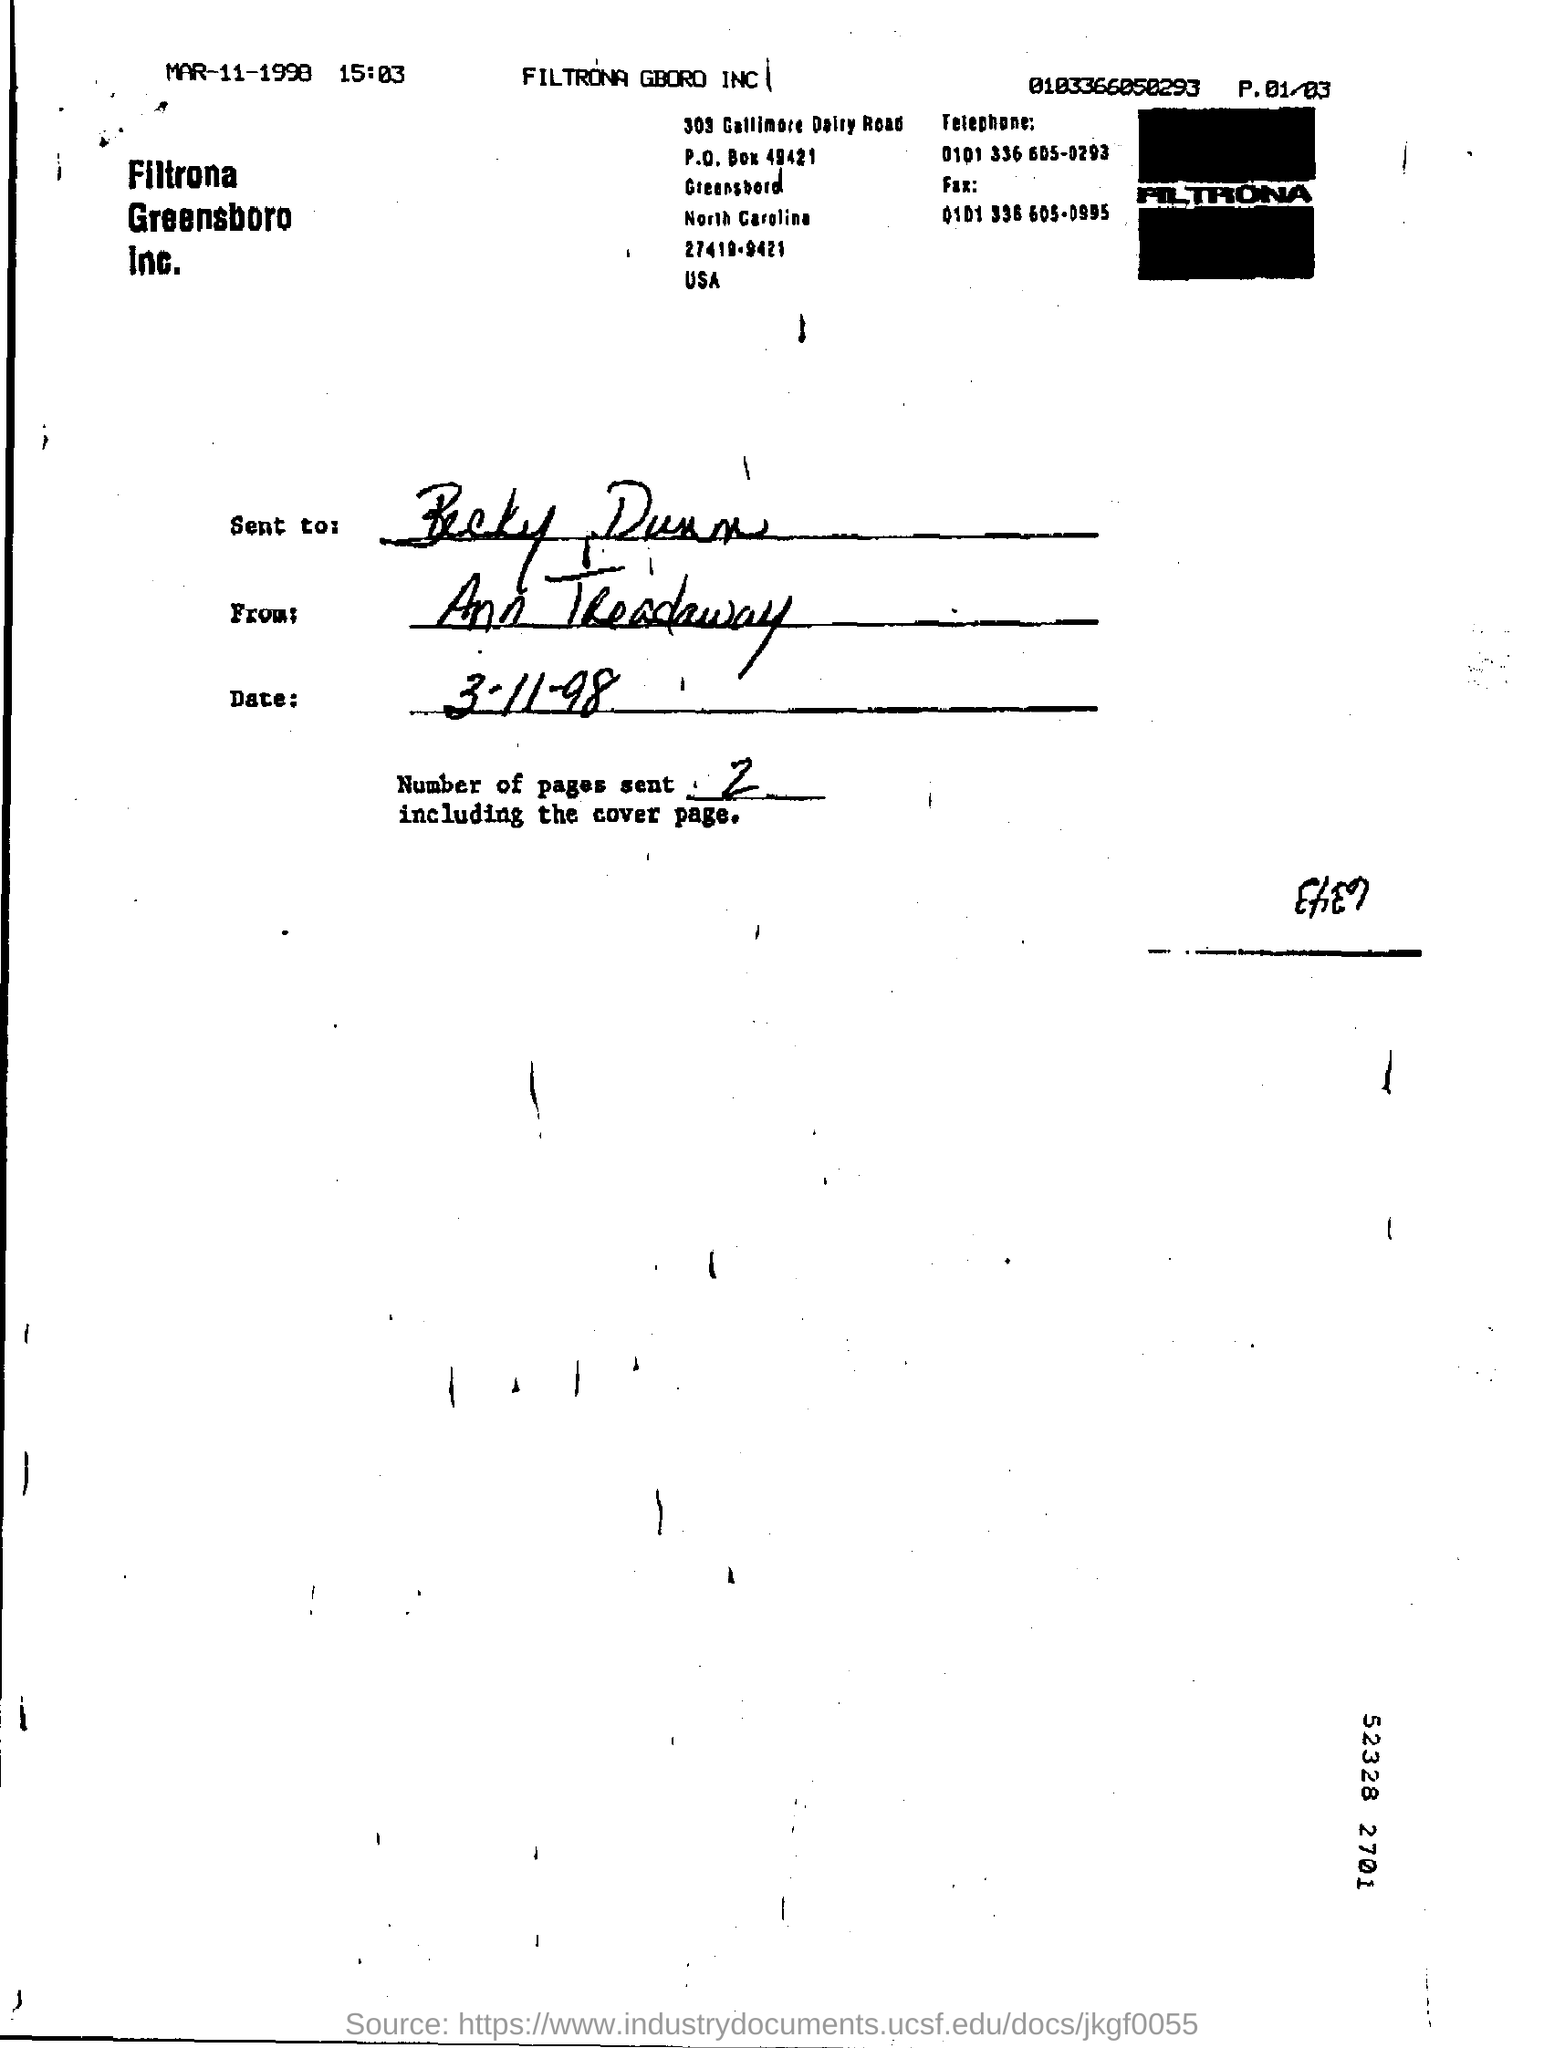To whom was this document sent?
Your response must be concise. Becky Dunn. From whom has this document been sent?
Your response must be concise. Ann Treadaway. What is the date mentioned in the Date column?
Give a very brief answer. 3-11-98. 